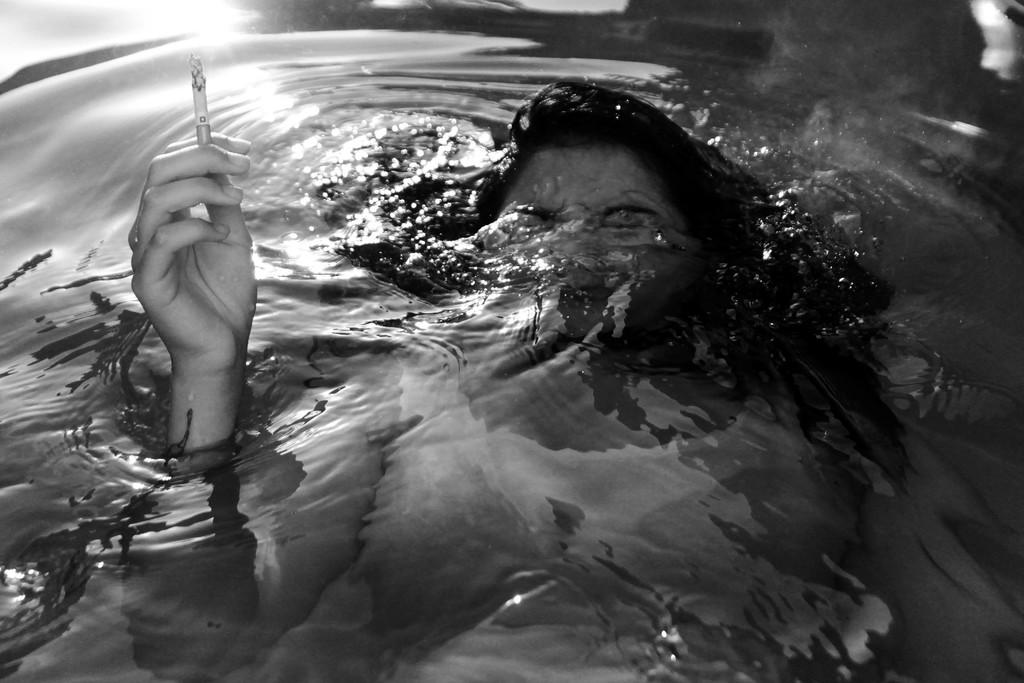Who is the main subject in the image? There is a woman in the image. What is the woman doing with her eyes? The woman has both eyes closed. What is the woman holding in her hand? The woman is holding a cigarette with one hand. Where is the woman's hand in relation to the water? The woman's hand is partially in the water. How would you describe the background of the image? The background of the image is dark in color. What type of form can be seen in the quicksand in the image? There is no quicksand present in the image, and therefore no form can be seen in it. 